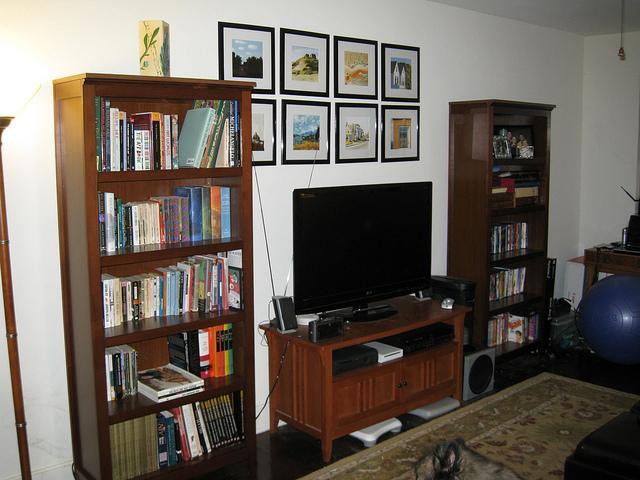What type of paint was used to paint the pictures hanging on the wall? acrylic 